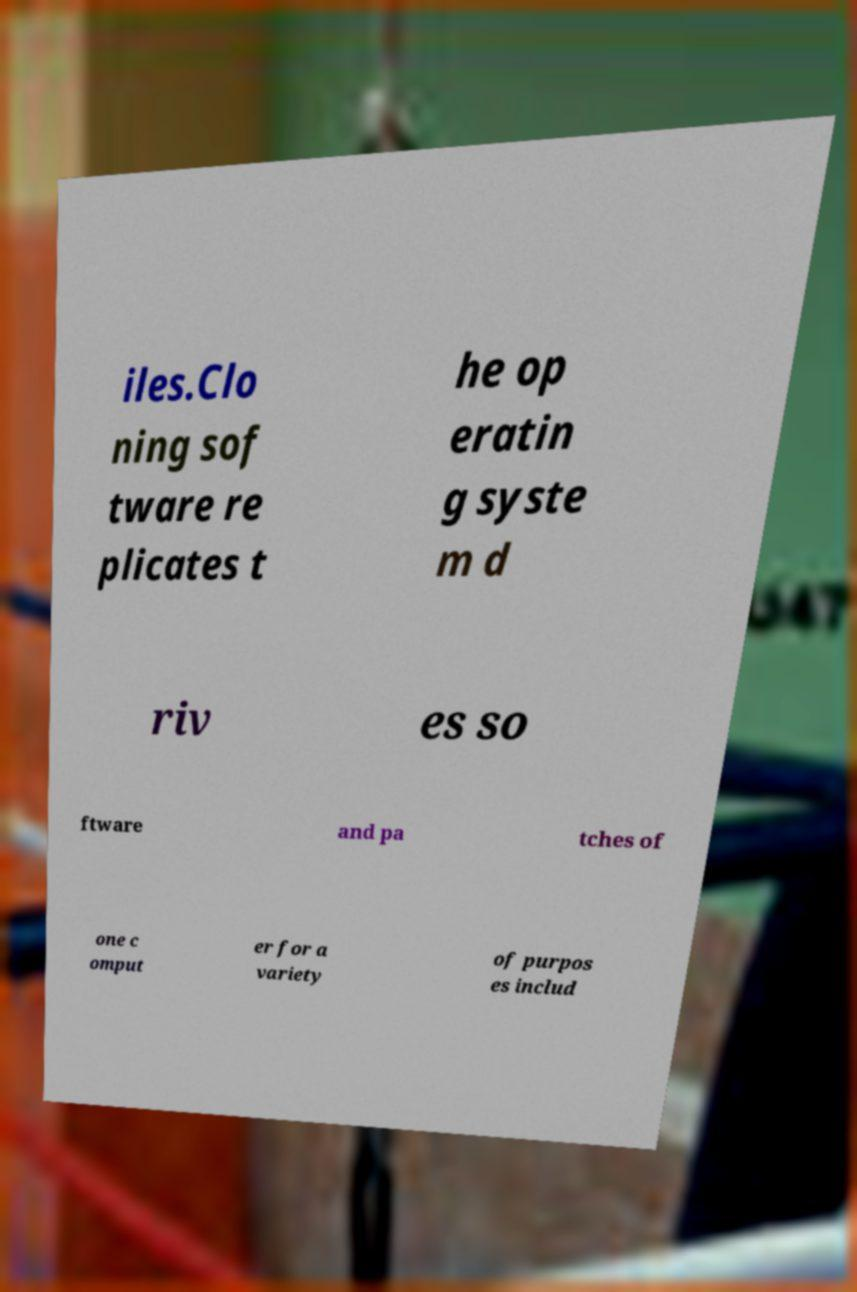For documentation purposes, I need the text within this image transcribed. Could you provide that? iles.Clo ning sof tware re plicates t he op eratin g syste m d riv es so ftware and pa tches of one c omput er for a variety of purpos es includ 